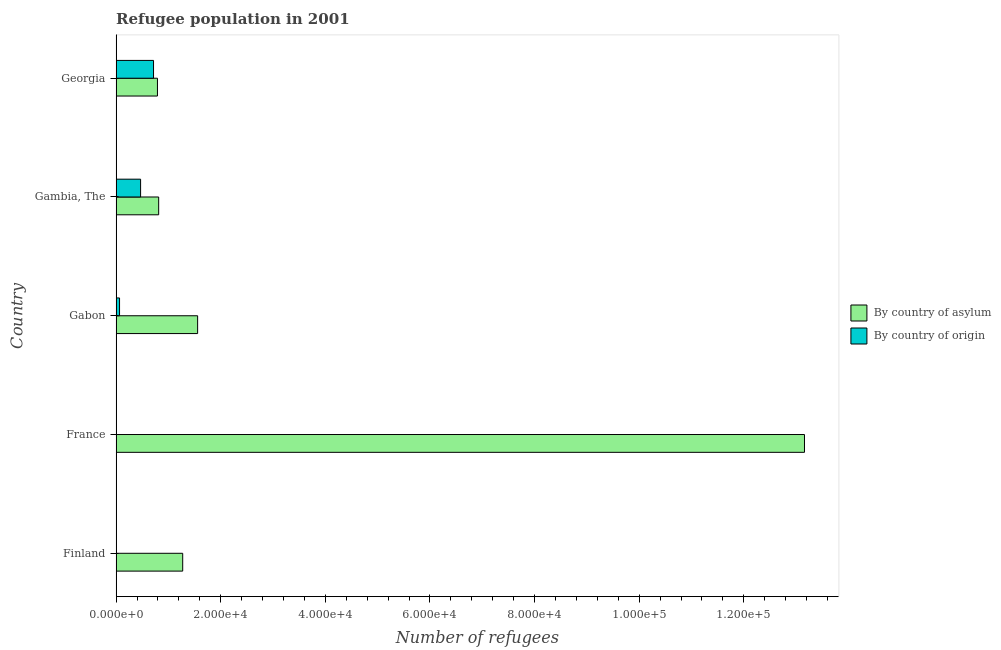How many different coloured bars are there?
Ensure brevity in your answer.  2. How many groups of bars are there?
Provide a succinct answer. 5. Are the number of bars on each tick of the Y-axis equal?
Provide a succinct answer. Yes. How many bars are there on the 1st tick from the bottom?
Offer a very short reply. 2. What is the label of the 4th group of bars from the top?
Your response must be concise. France. What is the number of refugees by country of origin in Finland?
Make the answer very short. 5. Across all countries, what is the maximum number of refugees by country of asylum?
Offer a terse response. 1.32e+05. Across all countries, what is the minimum number of refugees by country of asylum?
Make the answer very short. 7901. In which country was the number of refugees by country of asylum maximum?
Your response must be concise. France. In which country was the number of refugees by country of origin minimum?
Keep it short and to the point. Finland. What is the total number of refugees by country of origin in the graph?
Give a very brief answer. 1.25e+04. What is the difference between the number of refugees by country of asylum in Gabon and that in Georgia?
Ensure brevity in your answer.  7680. What is the difference between the number of refugees by country of origin in Finland and the number of refugees by country of asylum in Gabon?
Give a very brief answer. -1.56e+04. What is the average number of refugees by country of asylum per country?
Give a very brief answer. 3.52e+04. What is the difference between the number of refugees by country of origin and number of refugees by country of asylum in France?
Ensure brevity in your answer.  -1.32e+05. In how many countries, is the number of refugees by country of origin greater than 56000 ?
Make the answer very short. 0. What is the ratio of the number of refugees by country of origin in Gabon to that in Georgia?
Offer a very short reply. 0.09. What is the difference between the highest and the second highest number of refugees by country of origin?
Your answer should be compact. 2472. What is the difference between the highest and the lowest number of refugees by country of origin?
Make the answer very short. 7145. In how many countries, is the number of refugees by country of asylum greater than the average number of refugees by country of asylum taken over all countries?
Offer a terse response. 1. What does the 2nd bar from the top in Georgia represents?
Your answer should be very brief. By country of asylum. What does the 2nd bar from the bottom in Georgia represents?
Give a very brief answer. By country of origin. How many bars are there?
Provide a short and direct response. 10. Are all the bars in the graph horizontal?
Your answer should be compact. Yes. How many countries are there in the graph?
Give a very brief answer. 5. Does the graph contain any zero values?
Make the answer very short. No. Does the graph contain grids?
Your answer should be very brief. No. What is the title of the graph?
Provide a succinct answer. Refugee population in 2001. What is the label or title of the X-axis?
Keep it short and to the point. Number of refugees. What is the label or title of the Y-axis?
Your answer should be very brief. Country. What is the Number of refugees of By country of asylum in Finland?
Offer a very short reply. 1.27e+04. What is the Number of refugees in By country of origin in Finland?
Your response must be concise. 5. What is the Number of refugees in By country of asylum in France?
Give a very brief answer. 1.32e+05. What is the Number of refugees in By country of asylum in Gabon?
Give a very brief answer. 1.56e+04. What is the Number of refugees in By country of origin in Gabon?
Ensure brevity in your answer.  653. What is the Number of refugees in By country of asylum in Gambia, The?
Give a very brief answer. 8133. What is the Number of refugees in By country of origin in Gambia, The?
Offer a very short reply. 4678. What is the Number of refugees in By country of asylum in Georgia?
Offer a very short reply. 7901. What is the Number of refugees in By country of origin in Georgia?
Provide a short and direct response. 7150. Across all countries, what is the maximum Number of refugees in By country of asylum?
Ensure brevity in your answer.  1.32e+05. Across all countries, what is the maximum Number of refugees in By country of origin?
Offer a terse response. 7150. Across all countries, what is the minimum Number of refugees of By country of asylum?
Give a very brief answer. 7901. Across all countries, what is the minimum Number of refugees of By country of origin?
Give a very brief answer. 5. What is the total Number of refugees in By country of asylum in the graph?
Give a very brief answer. 1.76e+05. What is the total Number of refugees in By country of origin in the graph?
Your answer should be very brief. 1.25e+04. What is the difference between the Number of refugees of By country of asylum in Finland and that in France?
Provide a succinct answer. -1.19e+05. What is the difference between the Number of refugees in By country of origin in Finland and that in France?
Ensure brevity in your answer.  -41. What is the difference between the Number of refugees in By country of asylum in Finland and that in Gabon?
Offer a terse response. -2853. What is the difference between the Number of refugees in By country of origin in Finland and that in Gabon?
Provide a short and direct response. -648. What is the difference between the Number of refugees in By country of asylum in Finland and that in Gambia, The?
Provide a succinct answer. 4595. What is the difference between the Number of refugees of By country of origin in Finland and that in Gambia, The?
Provide a succinct answer. -4673. What is the difference between the Number of refugees in By country of asylum in Finland and that in Georgia?
Your response must be concise. 4827. What is the difference between the Number of refugees of By country of origin in Finland and that in Georgia?
Your answer should be compact. -7145. What is the difference between the Number of refugees of By country of asylum in France and that in Gabon?
Provide a succinct answer. 1.16e+05. What is the difference between the Number of refugees in By country of origin in France and that in Gabon?
Make the answer very short. -607. What is the difference between the Number of refugees of By country of asylum in France and that in Gambia, The?
Provide a short and direct response. 1.23e+05. What is the difference between the Number of refugees in By country of origin in France and that in Gambia, The?
Ensure brevity in your answer.  -4632. What is the difference between the Number of refugees in By country of asylum in France and that in Georgia?
Offer a terse response. 1.24e+05. What is the difference between the Number of refugees of By country of origin in France and that in Georgia?
Offer a terse response. -7104. What is the difference between the Number of refugees of By country of asylum in Gabon and that in Gambia, The?
Ensure brevity in your answer.  7448. What is the difference between the Number of refugees in By country of origin in Gabon and that in Gambia, The?
Provide a short and direct response. -4025. What is the difference between the Number of refugees in By country of asylum in Gabon and that in Georgia?
Offer a very short reply. 7680. What is the difference between the Number of refugees of By country of origin in Gabon and that in Georgia?
Provide a short and direct response. -6497. What is the difference between the Number of refugees in By country of asylum in Gambia, The and that in Georgia?
Offer a terse response. 232. What is the difference between the Number of refugees in By country of origin in Gambia, The and that in Georgia?
Give a very brief answer. -2472. What is the difference between the Number of refugees in By country of asylum in Finland and the Number of refugees in By country of origin in France?
Your response must be concise. 1.27e+04. What is the difference between the Number of refugees in By country of asylum in Finland and the Number of refugees in By country of origin in Gabon?
Your response must be concise. 1.21e+04. What is the difference between the Number of refugees in By country of asylum in Finland and the Number of refugees in By country of origin in Gambia, The?
Your answer should be compact. 8050. What is the difference between the Number of refugees of By country of asylum in Finland and the Number of refugees of By country of origin in Georgia?
Offer a very short reply. 5578. What is the difference between the Number of refugees in By country of asylum in France and the Number of refugees in By country of origin in Gabon?
Your answer should be compact. 1.31e+05. What is the difference between the Number of refugees of By country of asylum in France and the Number of refugees of By country of origin in Gambia, The?
Ensure brevity in your answer.  1.27e+05. What is the difference between the Number of refugees in By country of asylum in France and the Number of refugees in By country of origin in Georgia?
Your response must be concise. 1.24e+05. What is the difference between the Number of refugees in By country of asylum in Gabon and the Number of refugees in By country of origin in Gambia, The?
Give a very brief answer. 1.09e+04. What is the difference between the Number of refugees of By country of asylum in Gabon and the Number of refugees of By country of origin in Georgia?
Provide a short and direct response. 8431. What is the difference between the Number of refugees in By country of asylum in Gambia, The and the Number of refugees in By country of origin in Georgia?
Ensure brevity in your answer.  983. What is the average Number of refugees of By country of asylum per country?
Make the answer very short. 3.52e+04. What is the average Number of refugees of By country of origin per country?
Make the answer very short. 2506.4. What is the difference between the Number of refugees in By country of asylum and Number of refugees in By country of origin in Finland?
Provide a short and direct response. 1.27e+04. What is the difference between the Number of refugees in By country of asylum and Number of refugees in By country of origin in France?
Your answer should be compact. 1.32e+05. What is the difference between the Number of refugees in By country of asylum and Number of refugees in By country of origin in Gabon?
Give a very brief answer. 1.49e+04. What is the difference between the Number of refugees of By country of asylum and Number of refugees of By country of origin in Gambia, The?
Your answer should be compact. 3455. What is the difference between the Number of refugees of By country of asylum and Number of refugees of By country of origin in Georgia?
Keep it short and to the point. 751. What is the ratio of the Number of refugees of By country of asylum in Finland to that in France?
Provide a short and direct response. 0.1. What is the ratio of the Number of refugees of By country of origin in Finland to that in France?
Keep it short and to the point. 0.11. What is the ratio of the Number of refugees in By country of asylum in Finland to that in Gabon?
Provide a short and direct response. 0.82. What is the ratio of the Number of refugees of By country of origin in Finland to that in Gabon?
Keep it short and to the point. 0.01. What is the ratio of the Number of refugees in By country of asylum in Finland to that in Gambia, The?
Keep it short and to the point. 1.56. What is the ratio of the Number of refugees in By country of origin in Finland to that in Gambia, The?
Offer a very short reply. 0. What is the ratio of the Number of refugees in By country of asylum in Finland to that in Georgia?
Your response must be concise. 1.61. What is the ratio of the Number of refugees of By country of origin in Finland to that in Georgia?
Your answer should be very brief. 0. What is the ratio of the Number of refugees of By country of asylum in France to that in Gabon?
Provide a succinct answer. 8.45. What is the ratio of the Number of refugees of By country of origin in France to that in Gabon?
Provide a succinct answer. 0.07. What is the ratio of the Number of refugees of By country of asylum in France to that in Gambia, The?
Make the answer very short. 16.18. What is the ratio of the Number of refugees in By country of origin in France to that in Gambia, The?
Your answer should be compact. 0.01. What is the ratio of the Number of refugees in By country of asylum in France to that in Georgia?
Ensure brevity in your answer.  16.66. What is the ratio of the Number of refugees in By country of origin in France to that in Georgia?
Give a very brief answer. 0.01. What is the ratio of the Number of refugees of By country of asylum in Gabon to that in Gambia, The?
Your answer should be very brief. 1.92. What is the ratio of the Number of refugees in By country of origin in Gabon to that in Gambia, The?
Give a very brief answer. 0.14. What is the ratio of the Number of refugees in By country of asylum in Gabon to that in Georgia?
Make the answer very short. 1.97. What is the ratio of the Number of refugees in By country of origin in Gabon to that in Georgia?
Provide a short and direct response. 0.09. What is the ratio of the Number of refugees of By country of asylum in Gambia, The to that in Georgia?
Offer a very short reply. 1.03. What is the ratio of the Number of refugees of By country of origin in Gambia, The to that in Georgia?
Provide a short and direct response. 0.65. What is the difference between the highest and the second highest Number of refugees of By country of asylum?
Your response must be concise. 1.16e+05. What is the difference between the highest and the second highest Number of refugees in By country of origin?
Make the answer very short. 2472. What is the difference between the highest and the lowest Number of refugees in By country of asylum?
Your response must be concise. 1.24e+05. What is the difference between the highest and the lowest Number of refugees of By country of origin?
Make the answer very short. 7145. 